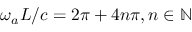Convert formula to latex. <formula><loc_0><loc_0><loc_500><loc_500>\omega _ { a } L / c = 2 \pi + 4 n \pi , n \in \mathbb { N }</formula> 